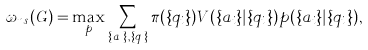<formula> <loc_0><loc_0><loc_500><loc_500>\omega _ { n s } ( G ) = \max _ { p } \sum _ { \{ a _ { i } \} , \{ q _ { i } \} } \pi ( \{ q _ { i } \} ) V ( \{ a _ { i } \} | \{ q _ { i } \} ) p ( \{ a _ { i } \} | \{ q _ { i } \} ) ,</formula> 